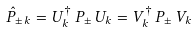<formula> <loc_0><loc_0><loc_500><loc_500>\hat { P } _ { \pm \, k } = U _ { k } ^ { \dagger } \, P _ { \pm } \, U _ { k } = V _ { k } ^ { \dagger } \, P _ { \pm } \, V _ { k }</formula> 